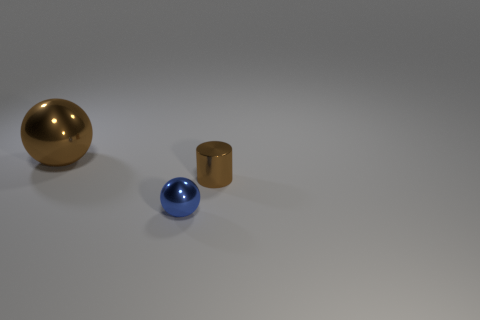What number of other metallic balls have the same size as the brown ball? 0 